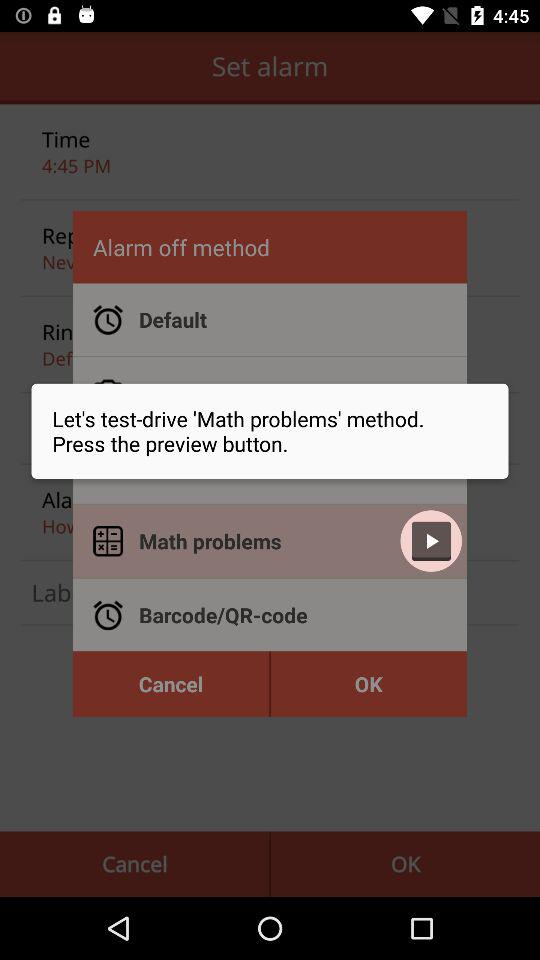What's the alarm time?
When the provided information is insufficient, respond with <no answer>. <no answer> 